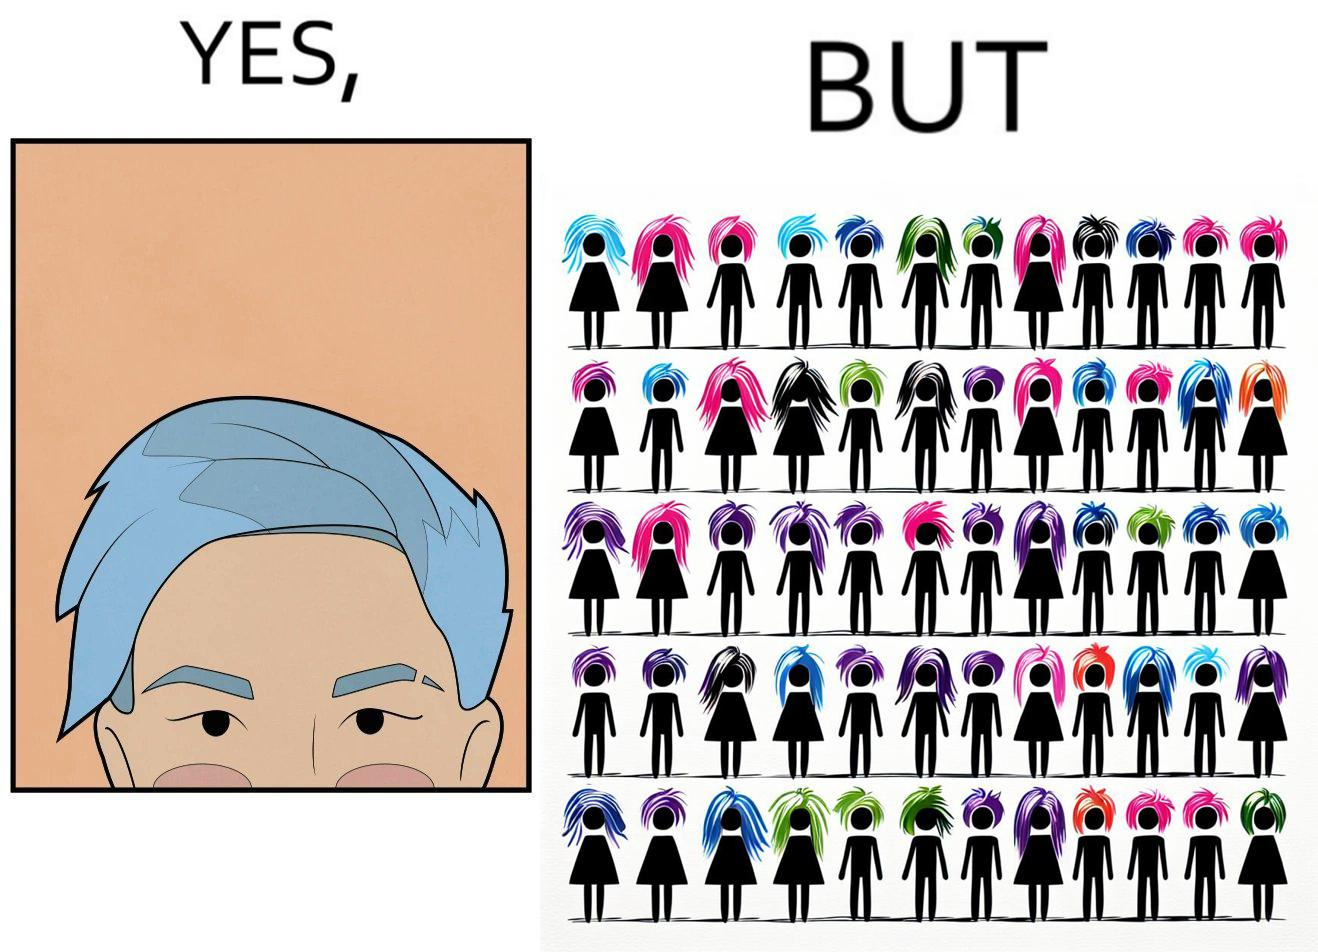What is shown in this image? The image is funny, as one person with a hair dyed blue seems to symbolize that the person is going against the grain, however, when we zoom out, the group of people have hair dyed in several, different colors, showing that, dyeing hair is the new normal. 